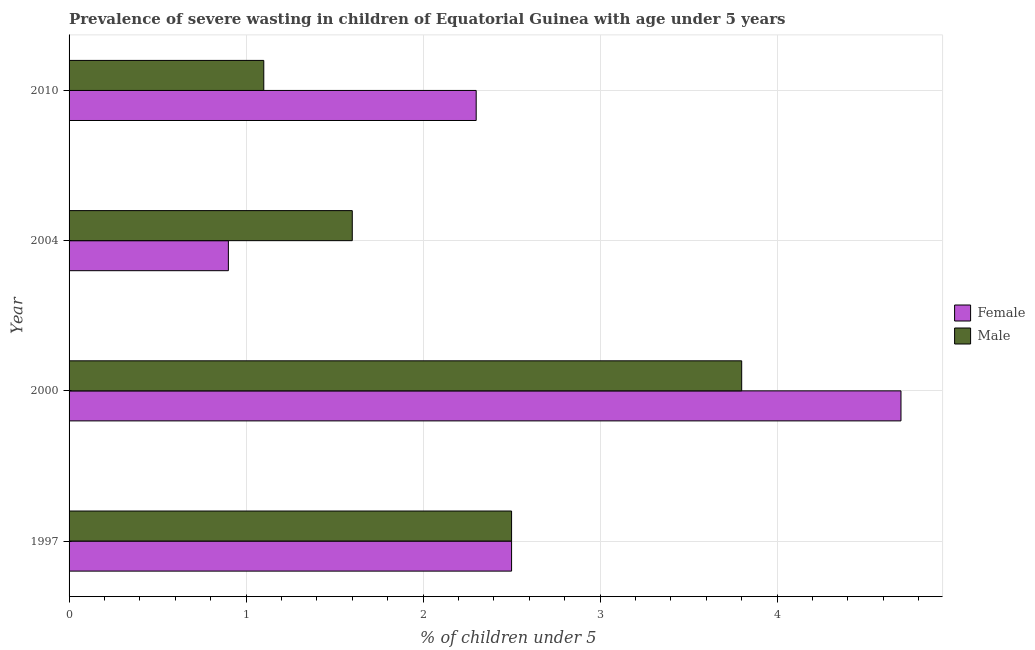How many different coloured bars are there?
Your response must be concise. 2. How many groups of bars are there?
Make the answer very short. 4. How many bars are there on the 1st tick from the top?
Your answer should be very brief. 2. In how many cases, is the number of bars for a given year not equal to the number of legend labels?
Keep it short and to the point. 0. What is the percentage of undernourished female children in 2000?
Provide a short and direct response. 4.7. Across all years, what is the maximum percentage of undernourished male children?
Your answer should be compact. 3.8. Across all years, what is the minimum percentage of undernourished male children?
Provide a short and direct response. 1.1. In which year was the percentage of undernourished female children minimum?
Keep it short and to the point. 2004. What is the difference between the percentage of undernourished female children in 2000 and that in 2010?
Keep it short and to the point. 2.4. What is the difference between the percentage of undernourished female children in 1997 and the percentage of undernourished male children in 2004?
Keep it short and to the point. 0.9. What is the average percentage of undernourished male children per year?
Make the answer very short. 2.25. In the year 2010, what is the difference between the percentage of undernourished male children and percentage of undernourished female children?
Provide a succinct answer. -1.2. In how many years, is the percentage of undernourished male children greater than 3.4 %?
Give a very brief answer. 1. What is the ratio of the percentage of undernourished male children in 1997 to that in 2010?
Provide a succinct answer. 2.27. What is the difference between the highest and the second highest percentage of undernourished male children?
Offer a very short reply. 1.3. In how many years, is the percentage of undernourished male children greater than the average percentage of undernourished male children taken over all years?
Your answer should be compact. 2. How many bars are there?
Make the answer very short. 8. What is the difference between two consecutive major ticks on the X-axis?
Give a very brief answer. 1. Are the values on the major ticks of X-axis written in scientific E-notation?
Provide a short and direct response. No. Does the graph contain any zero values?
Give a very brief answer. No. Does the graph contain grids?
Ensure brevity in your answer.  Yes. What is the title of the graph?
Your answer should be compact. Prevalence of severe wasting in children of Equatorial Guinea with age under 5 years. What is the label or title of the X-axis?
Provide a succinct answer.  % of children under 5. What is the label or title of the Y-axis?
Provide a short and direct response. Year. What is the  % of children under 5 in Male in 1997?
Provide a short and direct response. 2.5. What is the  % of children under 5 in Female in 2000?
Provide a short and direct response. 4.7. What is the  % of children under 5 of Male in 2000?
Ensure brevity in your answer.  3.8. What is the  % of children under 5 of Female in 2004?
Give a very brief answer. 0.9. What is the  % of children under 5 of Male in 2004?
Your answer should be compact. 1.6. What is the  % of children under 5 of Female in 2010?
Your answer should be compact. 2.3. What is the  % of children under 5 in Male in 2010?
Provide a succinct answer. 1.1. Across all years, what is the maximum  % of children under 5 of Female?
Make the answer very short. 4.7. Across all years, what is the maximum  % of children under 5 in Male?
Keep it short and to the point. 3.8. Across all years, what is the minimum  % of children under 5 in Female?
Offer a terse response. 0.9. Across all years, what is the minimum  % of children under 5 in Male?
Your answer should be very brief. 1.1. What is the difference between the  % of children under 5 of Male in 1997 and that in 2000?
Give a very brief answer. -1.3. What is the difference between the  % of children under 5 in Male in 1997 and that in 2010?
Keep it short and to the point. 1.4. What is the difference between the  % of children under 5 of Male in 2000 and that in 2004?
Your answer should be compact. 2.2. What is the difference between the  % of children under 5 of Male in 2004 and that in 2010?
Provide a succinct answer. 0.5. What is the difference between the  % of children under 5 in Female in 1997 and the  % of children under 5 in Male in 2000?
Provide a short and direct response. -1.3. What is the difference between the  % of children under 5 of Female in 1997 and the  % of children under 5 of Male in 2004?
Make the answer very short. 0.9. What is the average  % of children under 5 of Female per year?
Provide a short and direct response. 2.6. What is the average  % of children under 5 of Male per year?
Provide a succinct answer. 2.25. In the year 1997, what is the difference between the  % of children under 5 in Female and  % of children under 5 in Male?
Your answer should be very brief. 0. What is the ratio of the  % of children under 5 in Female in 1997 to that in 2000?
Give a very brief answer. 0.53. What is the ratio of the  % of children under 5 in Male in 1997 to that in 2000?
Make the answer very short. 0.66. What is the ratio of the  % of children under 5 of Female in 1997 to that in 2004?
Your answer should be compact. 2.78. What is the ratio of the  % of children under 5 of Male in 1997 to that in 2004?
Provide a succinct answer. 1.56. What is the ratio of the  % of children under 5 in Female in 1997 to that in 2010?
Give a very brief answer. 1.09. What is the ratio of the  % of children under 5 of Male in 1997 to that in 2010?
Offer a very short reply. 2.27. What is the ratio of the  % of children under 5 of Female in 2000 to that in 2004?
Keep it short and to the point. 5.22. What is the ratio of the  % of children under 5 of Male in 2000 to that in 2004?
Make the answer very short. 2.38. What is the ratio of the  % of children under 5 in Female in 2000 to that in 2010?
Keep it short and to the point. 2.04. What is the ratio of the  % of children under 5 in Male in 2000 to that in 2010?
Your answer should be very brief. 3.45. What is the ratio of the  % of children under 5 of Female in 2004 to that in 2010?
Your answer should be very brief. 0.39. What is the ratio of the  % of children under 5 in Male in 2004 to that in 2010?
Your answer should be compact. 1.45. What is the difference between the highest and the second highest  % of children under 5 of Female?
Keep it short and to the point. 2.2. What is the difference between the highest and the second highest  % of children under 5 of Male?
Offer a very short reply. 1.3. What is the difference between the highest and the lowest  % of children under 5 of Female?
Ensure brevity in your answer.  3.8. 